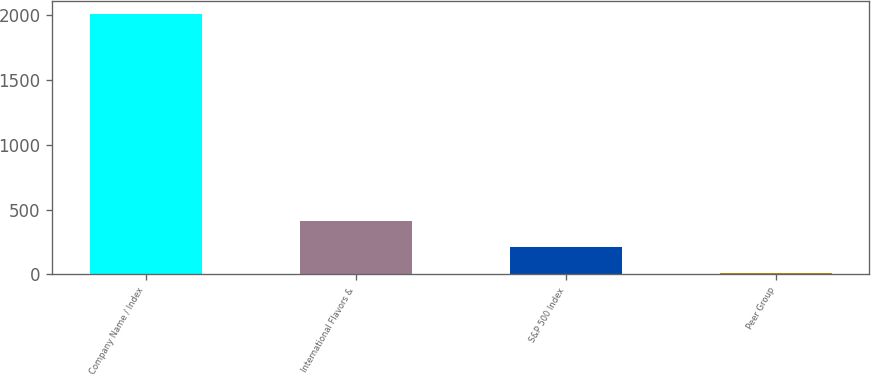Convert chart. <chart><loc_0><loc_0><loc_500><loc_500><bar_chart><fcel>Company Name / Index<fcel>International Flavors &<fcel>S&P 500 Index<fcel>Peer Group<nl><fcel>2012<fcel>408.97<fcel>208.59<fcel>8.21<nl></chart> 